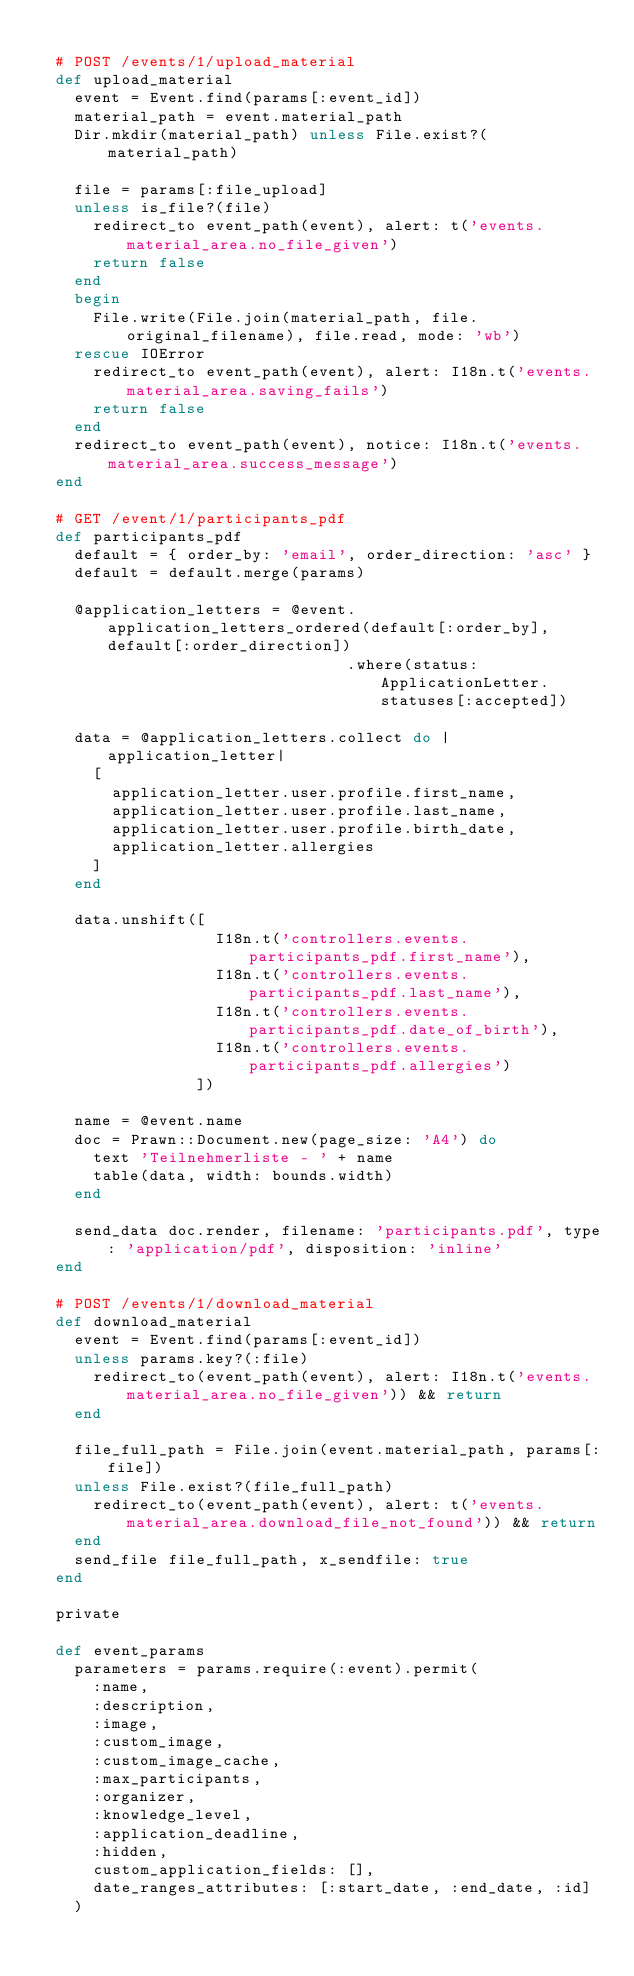<code> <loc_0><loc_0><loc_500><loc_500><_Ruby_>
  # POST /events/1/upload_material
  def upload_material
    event = Event.find(params[:event_id])
    material_path = event.material_path
    Dir.mkdir(material_path) unless File.exist?(material_path)

    file = params[:file_upload]
    unless is_file?(file)
      redirect_to event_path(event), alert: t('events.material_area.no_file_given')
      return false
    end
    begin
      File.write(File.join(material_path, file.original_filename), file.read, mode: 'wb')
    rescue IOError
      redirect_to event_path(event), alert: I18n.t('events.material_area.saving_fails')
      return false
    end
    redirect_to event_path(event), notice: I18n.t('events.material_area.success_message')
  end

  # GET /event/1/participants_pdf
  def participants_pdf
    default = { order_by: 'email', order_direction: 'asc' }
    default = default.merge(params)

    @application_letters = @event.application_letters_ordered(default[:order_by], default[:order_direction])
                                 .where(status: ApplicationLetter.statuses[:accepted])

    data = @application_letters.collect do |application_letter|
      [
        application_letter.user.profile.first_name,
        application_letter.user.profile.last_name,
        application_letter.user.profile.birth_date,
        application_letter.allergies
      ]
    end

    data.unshift([
                   I18n.t('controllers.events.participants_pdf.first_name'),
                   I18n.t('controllers.events.participants_pdf.last_name'),
                   I18n.t('controllers.events.participants_pdf.date_of_birth'),
                   I18n.t('controllers.events.participants_pdf.allergies')
                 ])

    name = @event.name
    doc = Prawn::Document.new(page_size: 'A4') do
      text 'Teilnehmerliste - ' + name
      table(data, width: bounds.width)
    end

    send_data doc.render, filename: 'participants.pdf', type: 'application/pdf', disposition: 'inline'
  end

  # POST /events/1/download_material
  def download_material
    event = Event.find(params[:event_id])
    unless params.key?(:file)
      redirect_to(event_path(event), alert: I18n.t('events.material_area.no_file_given')) && return
    end

    file_full_path = File.join(event.material_path, params[:file])
    unless File.exist?(file_full_path)
      redirect_to(event_path(event), alert: t('events.material_area.download_file_not_found')) && return
    end
    send_file file_full_path, x_sendfile: true
  end

  private

  def event_params
    parameters = params.require(:event).permit(
      :name,
      :description,
      :image,
      :custom_image,
      :custom_image_cache,
      :max_participants,
      :organizer,
      :knowledge_level,
      :application_deadline,
      :hidden,
      custom_application_fields: [],
      date_ranges_attributes: [:start_date, :end_date, :id]
    )</code> 